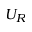<formula> <loc_0><loc_0><loc_500><loc_500>U _ { R }</formula> 